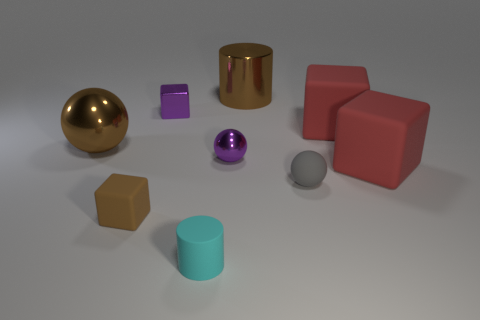Is there a red object made of the same material as the tiny brown object?
Give a very brief answer. Yes. The large brown thing that is left of the purple metal object that is to the right of the small shiny block is made of what material?
Give a very brief answer. Metal. Are there an equal number of big brown things in front of the brown cylinder and purple metal objects to the left of the tiny metal sphere?
Provide a succinct answer. Yes. Is the cyan thing the same shape as the gray rubber object?
Ensure brevity in your answer.  No. The brown object that is both behind the small metal ball and on the left side of the big cylinder is made of what material?
Make the answer very short. Metal. How many other tiny things have the same shape as the small cyan object?
Your answer should be very brief. 0. What is the size of the brown metallic object behind the big shiny object to the left of the purple thing to the left of the cyan thing?
Provide a succinct answer. Large. Are there more small brown cubes behind the gray rubber ball than small cyan objects?
Provide a succinct answer. No. Is there a blue object?
Your answer should be compact. No. How many brown metallic things are the same size as the purple metal sphere?
Make the answer very short. 0. 